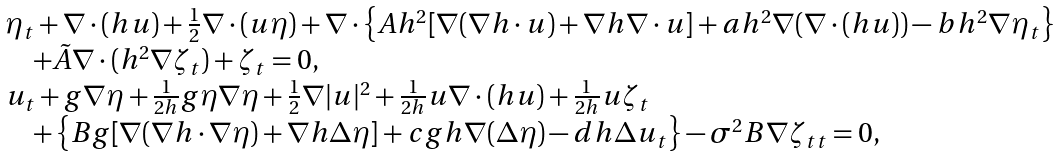Convert formula to latex. <formula><loc_0><loc_0><loc_500><loc_500>\begin{array} { l } \eta _ { t } + \nabla \cdot ( h { u } ) + \frac { 1 } { 2 } \nabla \cdot ( { u } \eta ) + \nabla \cdot \left \{ A h ^ { 2 } [ \nabla ( \nabla h \cdot { u } ) + \nabla h \nabla \cdot { u } ] + a h ^ { 2 } \nabla ( \nabla \cdot ( h { u } ) ) - b h ^ { 2 } \nabla \eta _ { t } \right \} \\ \quad + \tilde { A } \nabla \cdot ( h ^ { 2 } \nabla \zeta _ { t } ) + \zeta _ { t } = 0 , \\ { u } _ { t } + g \nabla \eta + \frac { 1 } { 2 h } g \eta \nabla \eta + \frac { 1 } { 2 } \nabla | { u } | ^ { 2 } + \frac { 1 } { 2 h } { u } \nabla \cdot ( h { u } ) + \frac { 1 } { 2 h } u \zeta _ { t } \\ \quad + \left \{ B g [ \nabla ( \nabla h \cdot \nabla \eta ) + \nabla h \Delta \eta ] + c g h \nabla ( \Delta \eta ) - d h \Delta { u } _ { t } \right \} - \sigma ^ { 2 } B \nabla \zeta _ { t t } = 0 , \end{array}</formula> 